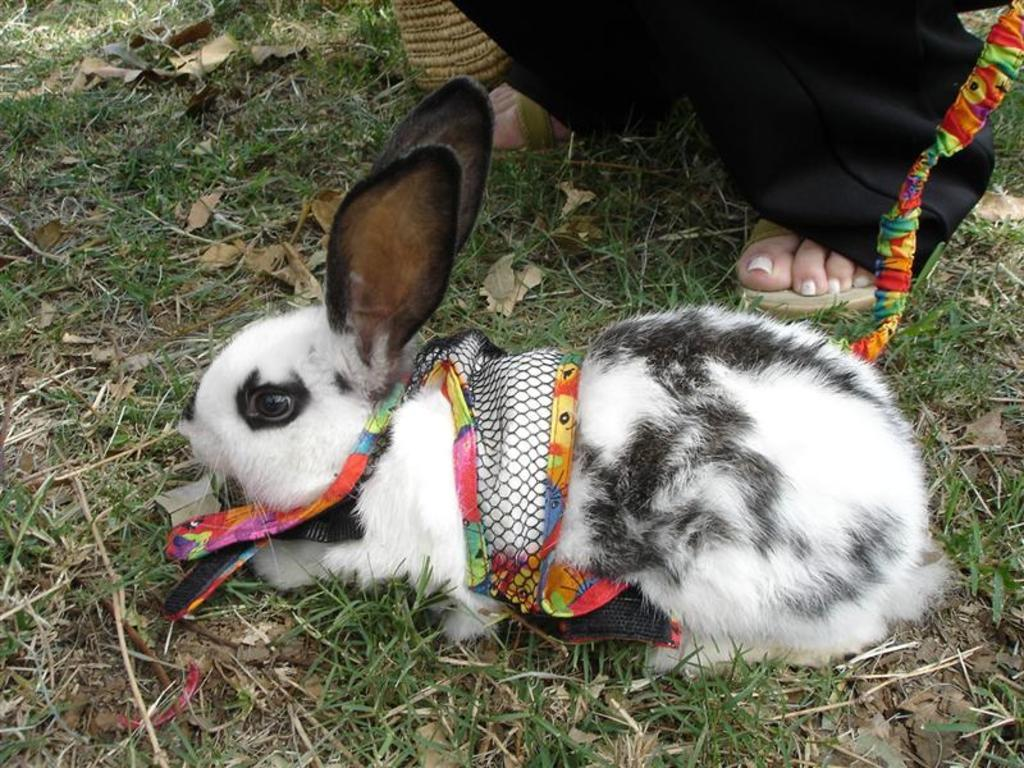What animal can be seen on the grass in the image? There is a rabbit on the grass in the image. How many people are present in the image? There are two people in the image. Can you describe the position of the two people in relation to each other? One person is beside another person. What force is being applied to the rabbit by the people in the image? There is no force being applied to the rabbit by the people in the image. 